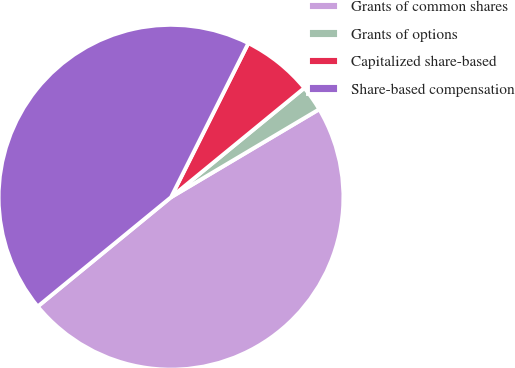Convert chart. <chart><loc_0><loc_0><loc_500><loc_500><pie_chart><fcel>Grants of common shares<fcel>Grants of options<fcel>Capitalized share-based<fcel>Share-based compensation<nl><fcel>47.6%<fcel>2.4%<fcel>6.67%<fcel>43.33%<nl></chart> 